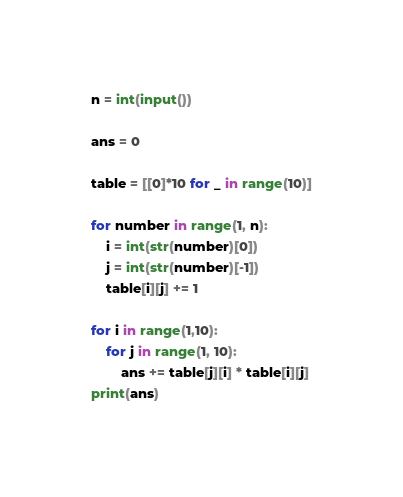Convert code to text. <code><loc_0><loc_0><loc_500><loc_500><_Python_>n = int(input())

ans = 0

table = [[0]*10 for _ in range(10)]

for number in range(1, n):
    i = int(str(number)[0])
    j = int(str(number)[-1])
    table[i][j] += 1

for i in range(1,10):
    for j in range(1, 10):
        ans += table[j][i] * table[i][j]
print(ans)

</code> 